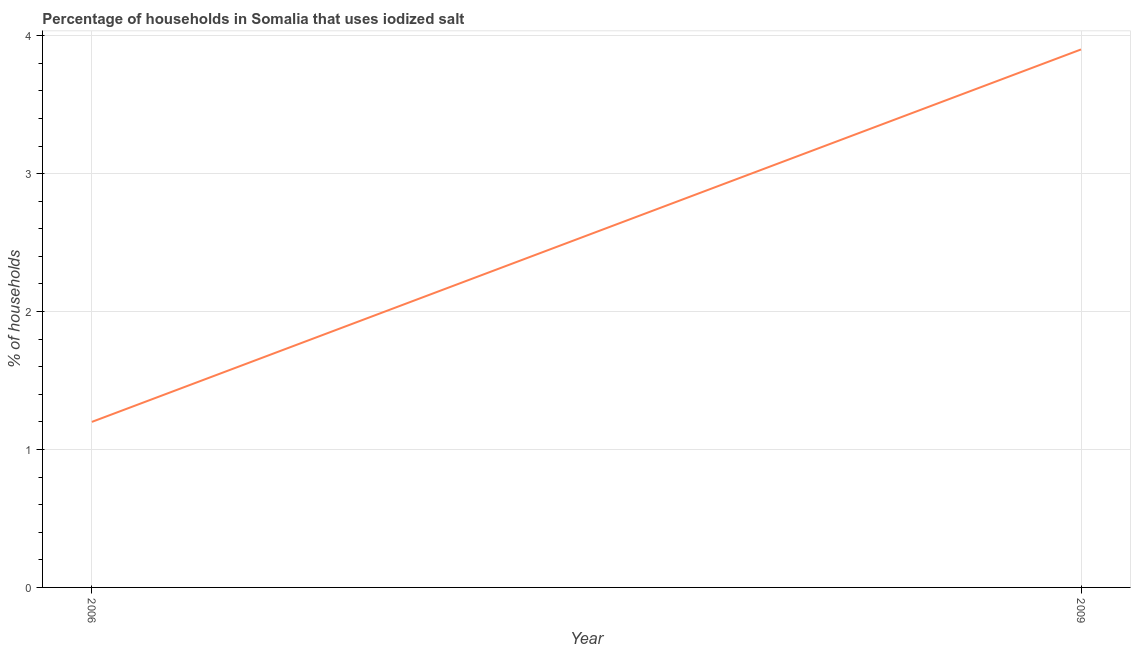Across all years, what is the minimum percentage of households where iodized salt is consumed?
Your answer should be compact. 1.2. In which year was the percentage of households where iodized salt is consumed maximum?
Ensure brevity in your answer.  2009. What is the difference between the percentage of households where iodized salt is consumed in 2006 and 2009?
Offer a terse response. -2.7. What is the average percentage of households where iodized salt is consumed per year?
Provide a short and direct response. 2.55. What is the median percentage of households where iodized salt is consumed?
Ensure brevity in your answer.  2.55. Do a majority of the years between 2009 and 2006 (inclusive) have percentage of households where iodized salt is consumed greater than 3 %?
Provide a succinct answer. No. What is the ratio of the percentage of households where iodized salt is consumed in 2006 to that in 2009?
Make the answer very short. 0.31. Does the graph contain any zero values?
Provide a short and direct response. No. What is the title of the graph?
Provide a short and direct response. Percentage of households in Somalia that uses iodized salt. What is the label or title of the X-axis?
Keep it short and to the point. Year. What is the label or title of the Y-axis?
Make the answer very short. % of households. What is the % of households in 2006?
Offer a very short reply. 1.2. What is the ratio of the % of households in 2006 to that in 2009?
Ensure brevity in your answer.  0.31. 